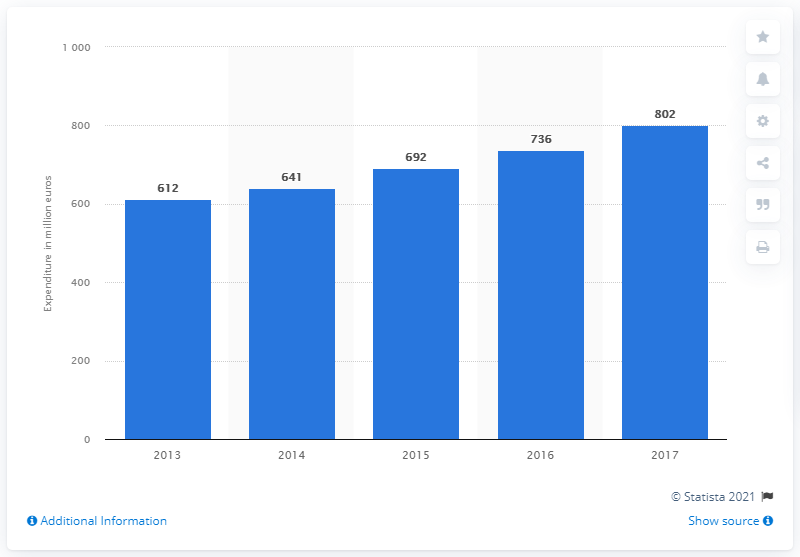Mention a couple of crucial points in this snapshot. The total expenditure on research and development in 2017 was 802... 